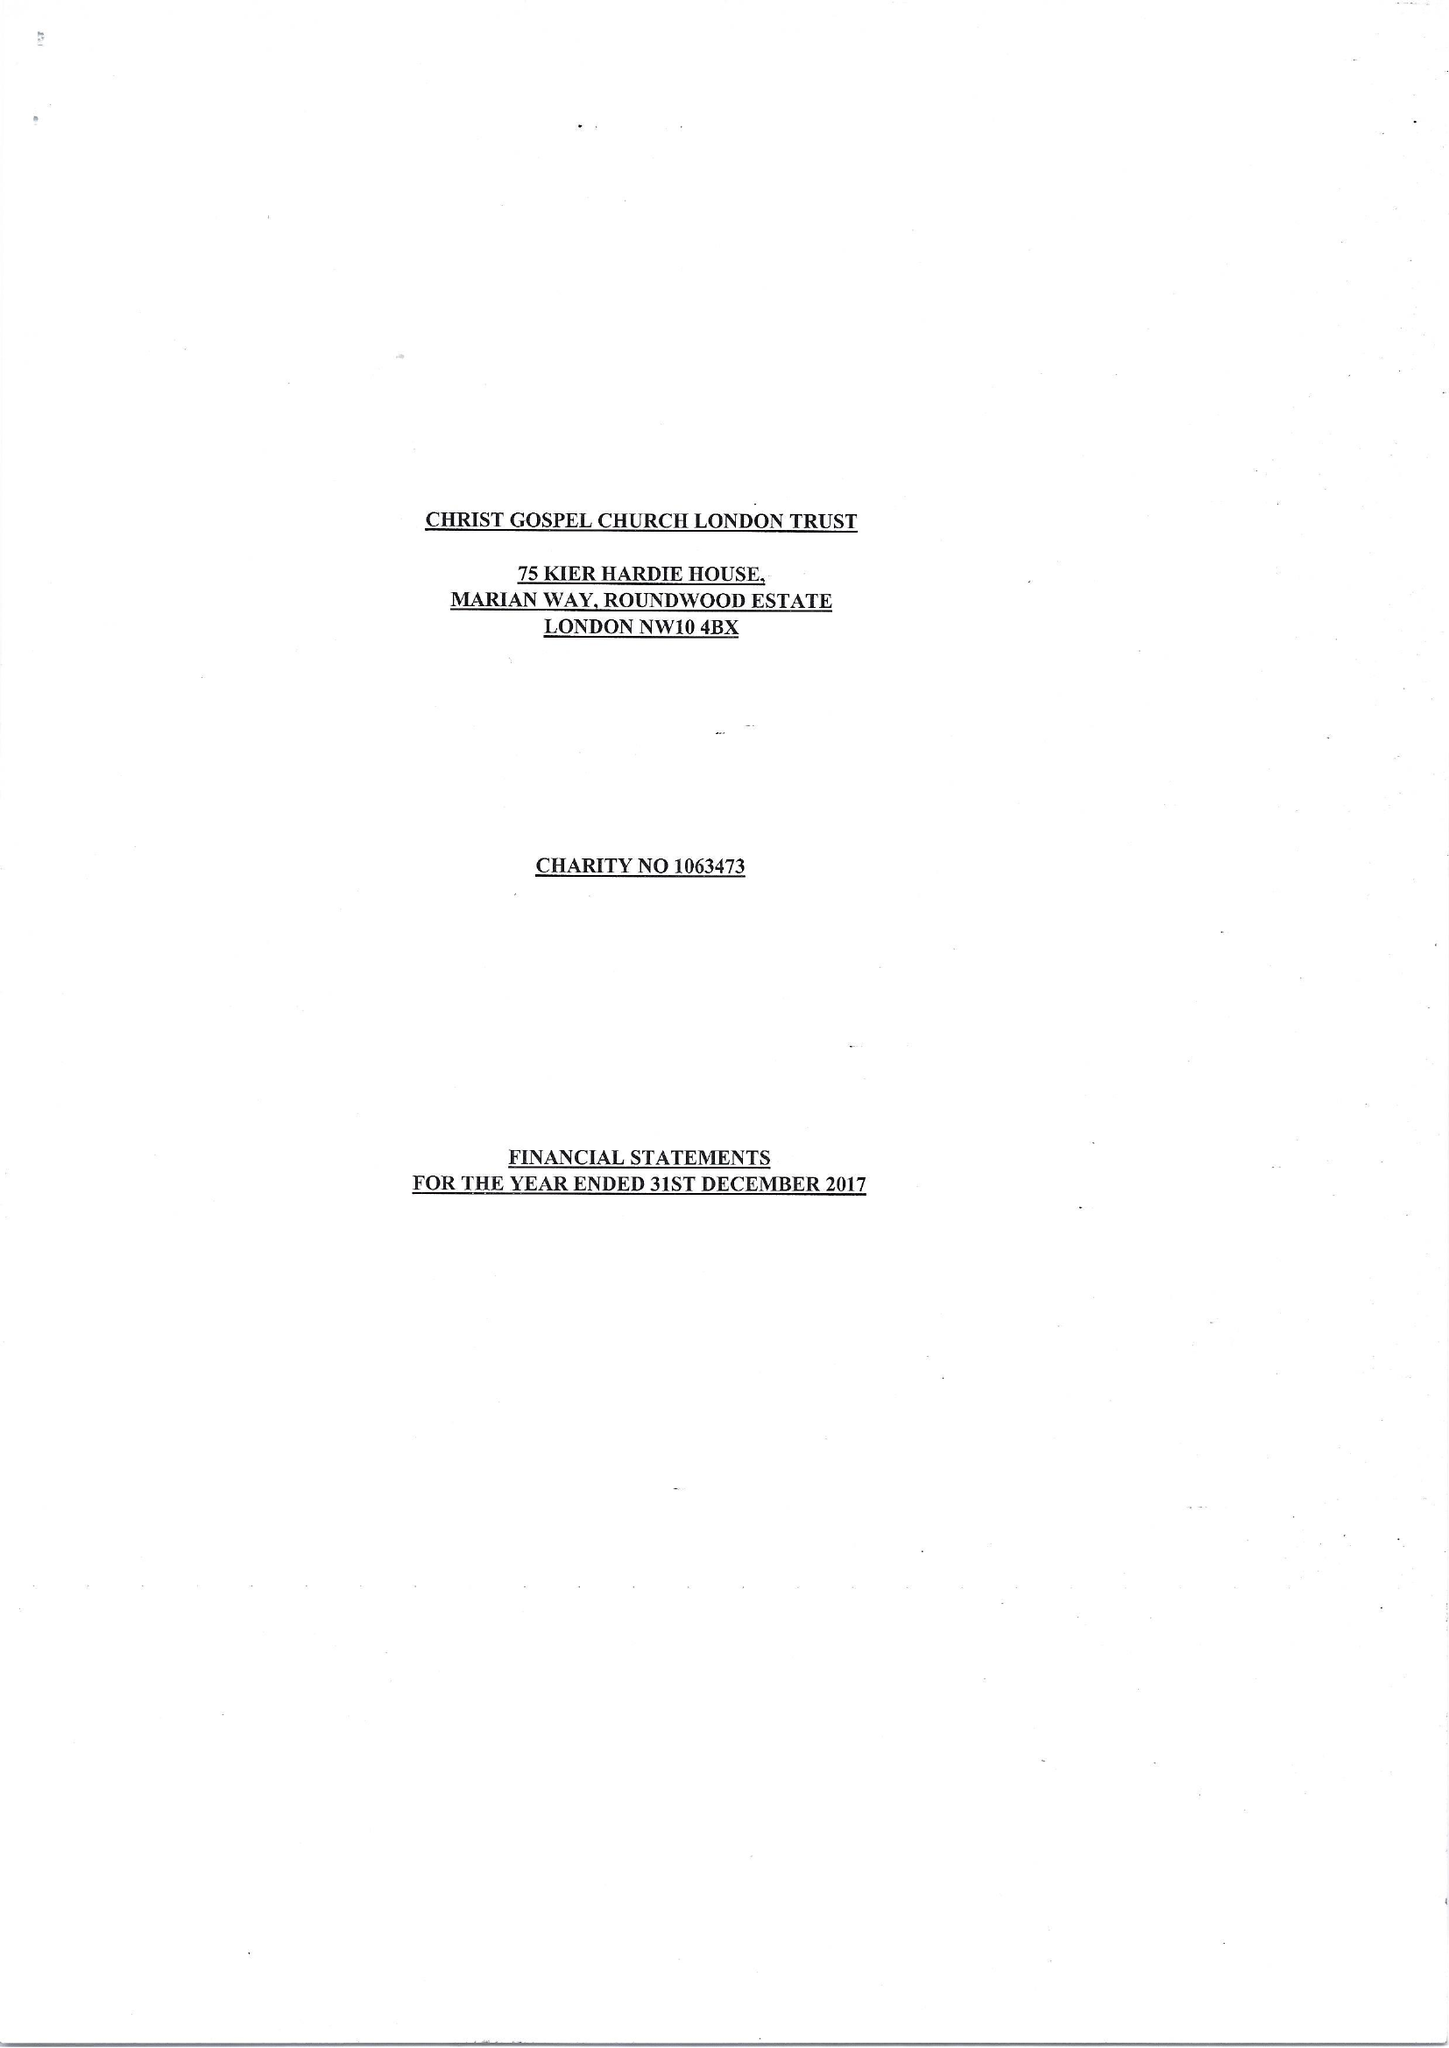What is the value for the income_annually_in_british_pounds?
Answer the question using a single word or phrase. 41461.00 